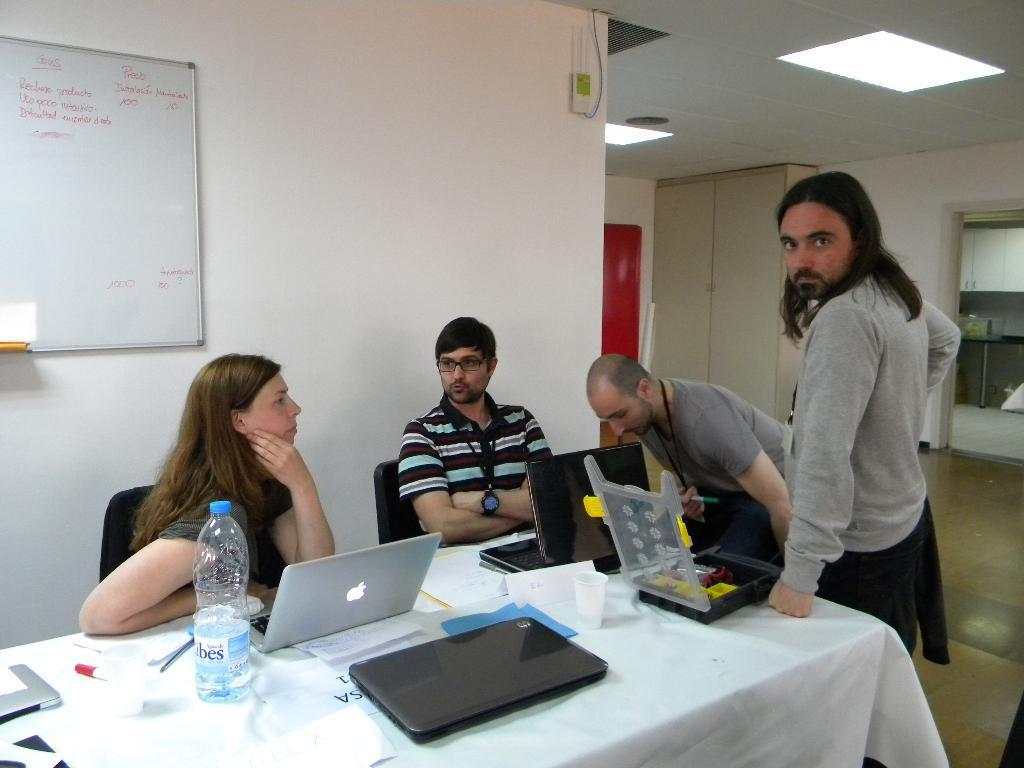In one or two sentences, can you explain what this image depicts? In the image we can see the four persons the two persons were sitting and the remaining two persons were standing,in front of table. On table we have laptop, bottle etc. Coming to the background we can see the wall and board. 